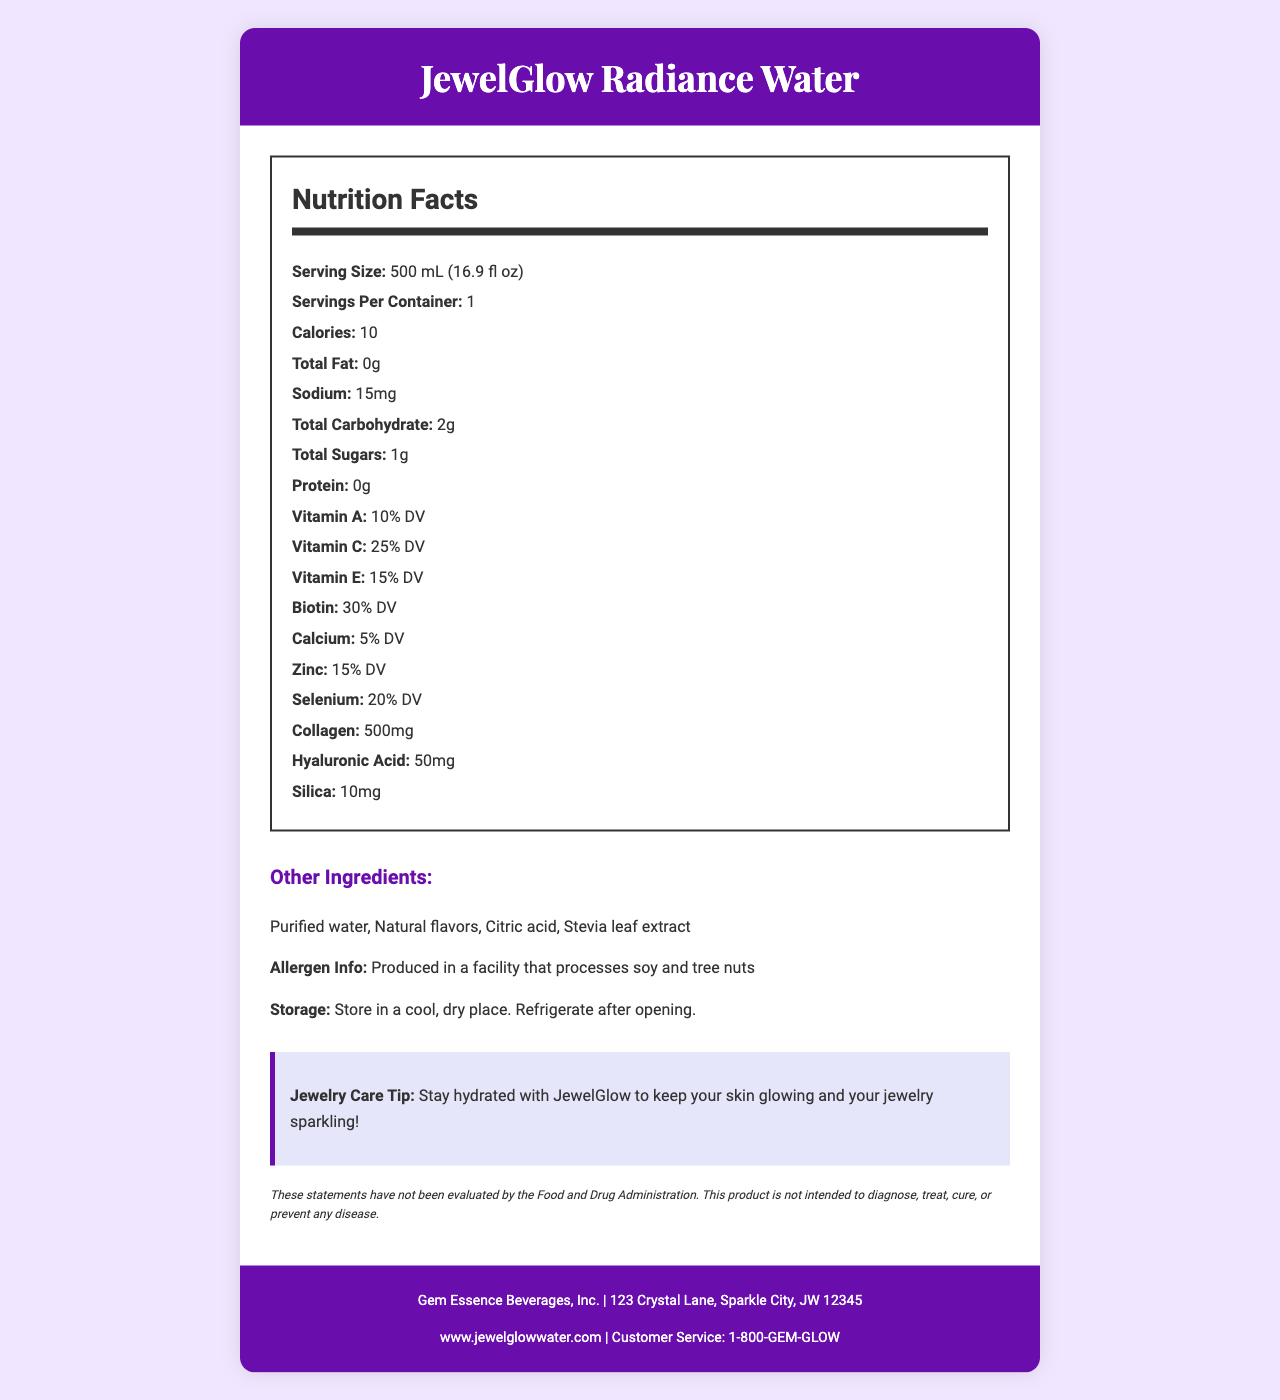what is the serving size? The serving size is listed as "500 mL (16.9 fl oz)" in the Nutrition Facts section.
Answer: 500 mL (16.9 fl oz) How many calories are there per serving? The document states that there are 10 calories per serving.
Answer: 10 calories What is the percentage of daily value for Vitamin A? The Nutrition Facts section shows that Vitamin A is 10% of the daily value.
Answer: 10% DV What are the main ingredients other than vitamins and minerals? These ingredients are listed under "Other Ingredients".
Answer: Purified water, Natural flavors, Citric acid, Stevia leaf extract What is the address of the manufacturer? The manufacturer's address is given at the bottom of the document.
Answer: 123 Crystal Lane, Sparkle City, JW 12345 Which vitamin has the highest daily value percentage? A. Vitamin A B. Vitamin C C. Vitamin E D. Biotin The daily value percentage for Biotin is 30% whereas Vitamin A is 10%, Vitamin C is 25%, and Vitamin E is 15%.
Answer: D. Biotin What is the sodium content in the drink? A. 0mg B. 10mg C. 15mg D. 20mg The sodium content is listed as 15mg in the Nutrition Facts.
Answer: C. 15mg Is this product intended to diagnose, treat, cure, or prevent any disease? The disclaimer states that "This product is not intended to diagnose, treat, cure, or prevent any disease."
Answer: No Do you need to refrigerate the product after opening? The storage instructions state "Refrigerate after opening."
Answer: Yes Summarize the main information in the document. This summary captures the essence of key data such as the product purpose, nutritional content, additional ingredients, allergen information, storage instructions, and manufacturing details.
Answer: JewelGlow Radiance Water is a vitamin-enriched mineral water designed to enhance skin and nail health, targeted at jewelry enthusiasts. It has a serving size of 500 mL with 10 calories per serving and contains various vitamins and minerals, including Vitamin A, C, E, Biotin, and additional ingredients like collagen. The product includes allergen information and storage instructions, and it's manufactured by Gem Essence Beverages, Inc. What is the exact amount of collagen in the JewelGlow Radiance Water? The document lists collagen at 500mg in the Nutrition Facts section.
Answer: 500mg What advice does the document give for jewelry care? This advice is given in the section labeled "Jewelry Care Tip".
Answer: Stay hydrated with JewelGlow to keep your skin glowing and your jewelry sparkling! Does the drink contain any protein? The protein content is listed as 0g in the Nutrition Facts.
Answer: No Where can you find more information about the product online? The website is provided at the bottom of the document.
Answer: www.jewelglowwater.com Which company produces JewelGlow Radiance Water? The manufacturer's name is listed at the bottom of the document.
Answer: Gem Essence Beverages, Inc. What is the total amount of sugar in one serving? The total sugar content per serving is stated as 1g in the Nutrition Facts.
Answer: 1g Is there information on the product that confirms it is suitable for vegetarians? The document does not specifically state whether the product is suitable for vegetarians.
Answer: Not enough information 